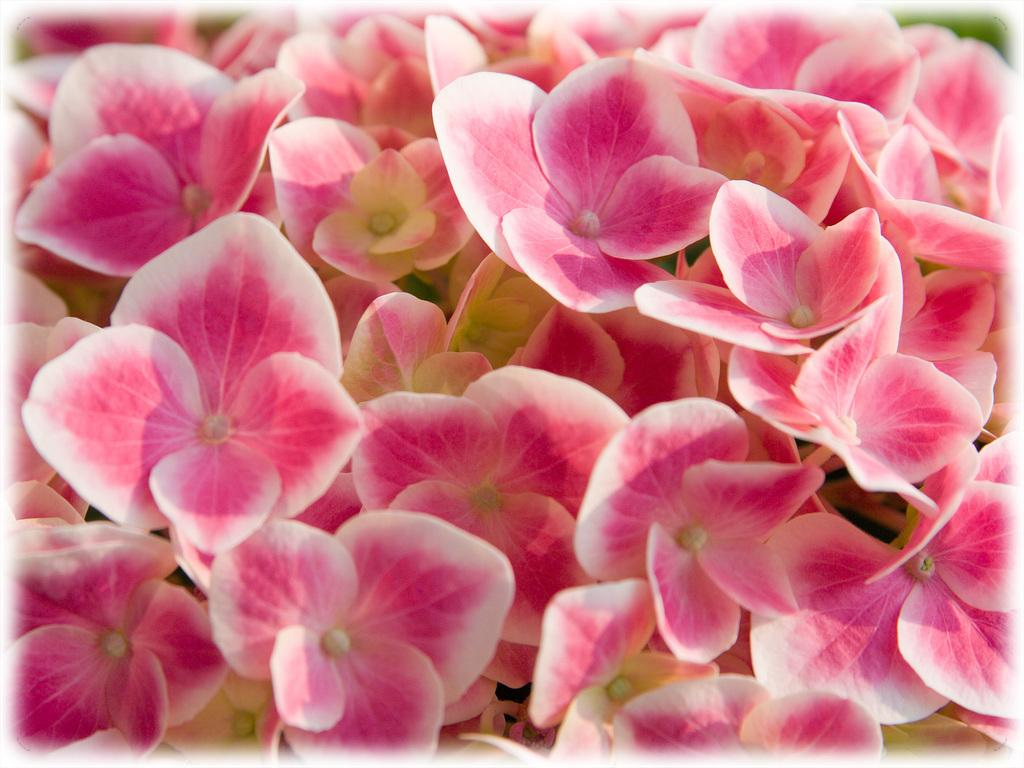What type of living organisms can be seen in the image? Flowers are visible in the image. What type of pot is the flower growing in within the image? There is no pot present in the image; only flowers are visible. Can you hear the flower crying in the image? Flowers do not have the ability to cry, and there is no indication of any sound in the image. 